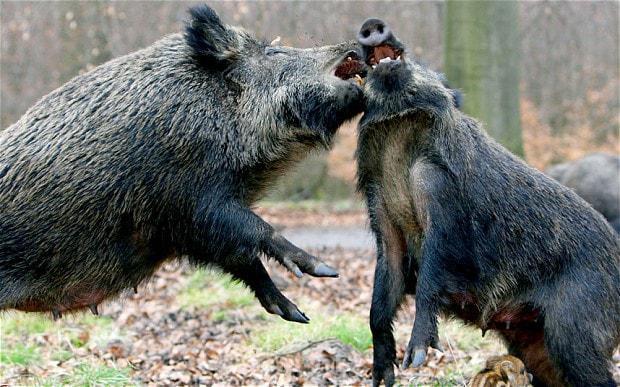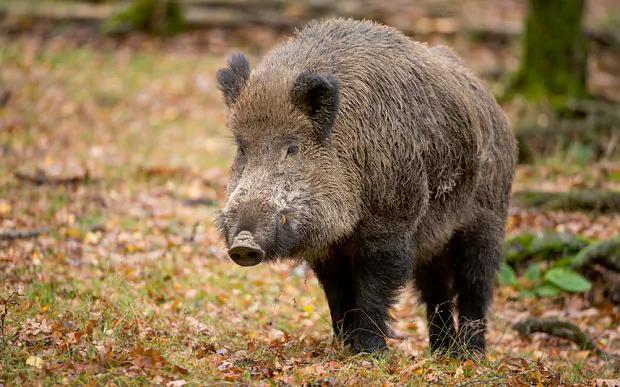The first image is the image on the left, the second image is the image on the right. Considering the images on both sides, is "There are two hogs in the pair of images ,both facing each other." valid? Answer yes or no. No. The first image is the image on the left, the second image is the image on the right. Examine the images to the left and right. Is the description "Each image contains a single wild pig, and the pigs in the right and left images appear to be facing each other." accurate? Answer yes or no. No. 